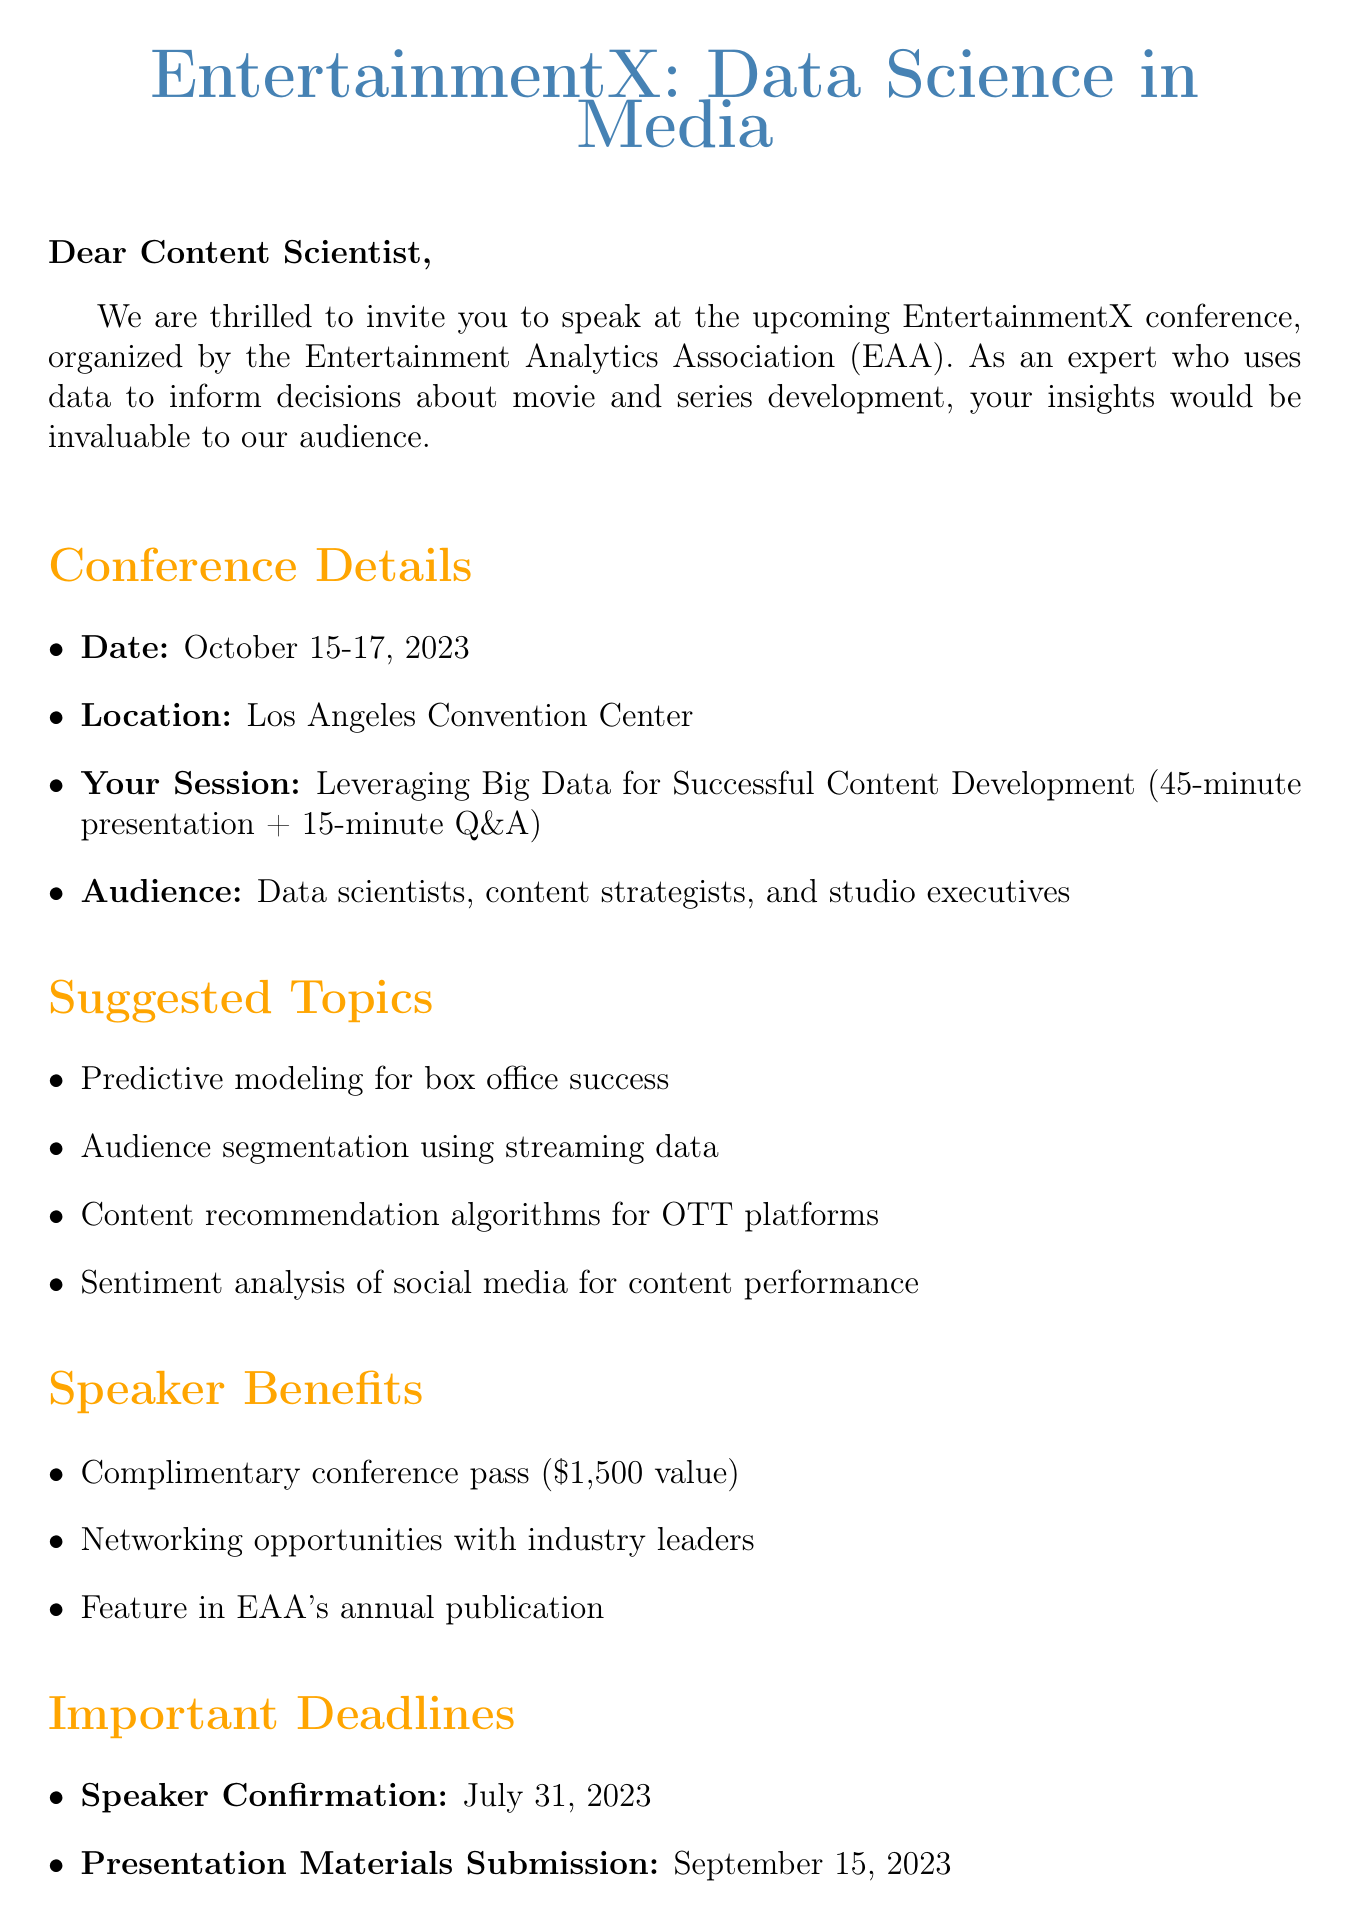What is the name of the conference? The name of the conference is mentioned in the document as "EntertainmentX: Data Science in Media."
Answer: EntertainmentX: Data Science in Media What are the conference dates? The document clearly states that the dates for the conference are October 15-17, 2023.
Answer: October 15-17, 2023 What is the location of the conference? The location provided in the document is the Los Angeles Convention Center.
Answer: Los Angeles Convention Center Who is the Conference Program Chair? The document identifies Dr. Emily Chen as the Conference Program Chair.
Answer: Dr. Emily Chen What is the duration of the speaker session? The document specifies that the speaker session includes a 45-minute presentation plus a 15-minute Q&A.
Answer: 45-minute presentation + 15-minute Q&A What benefit is mentioned for speakers regarding the conference pass? The document states that speakers will receive a complimentary conference pass valued at $1,500.
Answer: Complimentary conference pass ($1,500 value) What is the deadline for speaker confirmation? The document indicates that the deadline for speaker confirmation is July 31, 2023.
Answer: July 31, 2023 What type of audience will be present at the conference? The audience profile includes data scientists, content strategists, and studio executives as stated in the document.
Answer: Data scientists, content strategists, and studio executives What opportunity is highlighted for networking at the conference? The document mentions that there will be networking opportunities with industry leaders.
Answer: Networking opportunities with industry leaders 